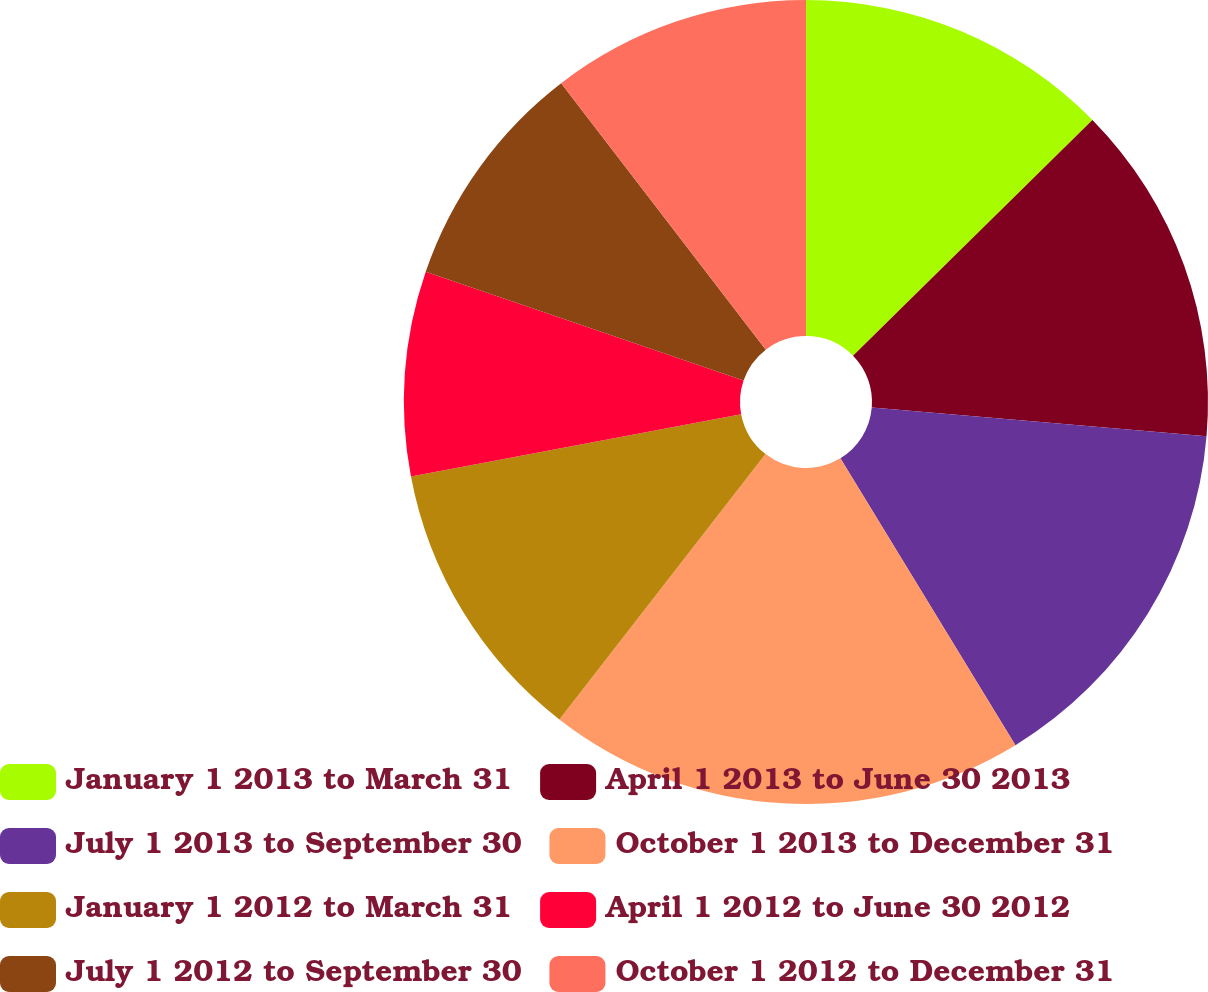Convert chart. <chart><loc_0><loc_0><loc_500><loc_500><pie_chart><fcel>January 1 2013 to March 31<fcel>April 1 2013 to June 30 2013<fcel>July 1 2013 to September 30<fcel>October 1 2013 to December 31<fcel>January 1 2012 to March 31<fcel>April 1 2012 to June 30 2012<fcel>July 1 2012 to September 30<fcel>October 1 2012 to December 31<nl><fcel>12.62%<fcel>13.73%<fcel>14.92%<fcel>19.23%<fcel>11.52%<fcel>8.22%<fcel>9.32%<fcel>10.42%<nl></chart> 